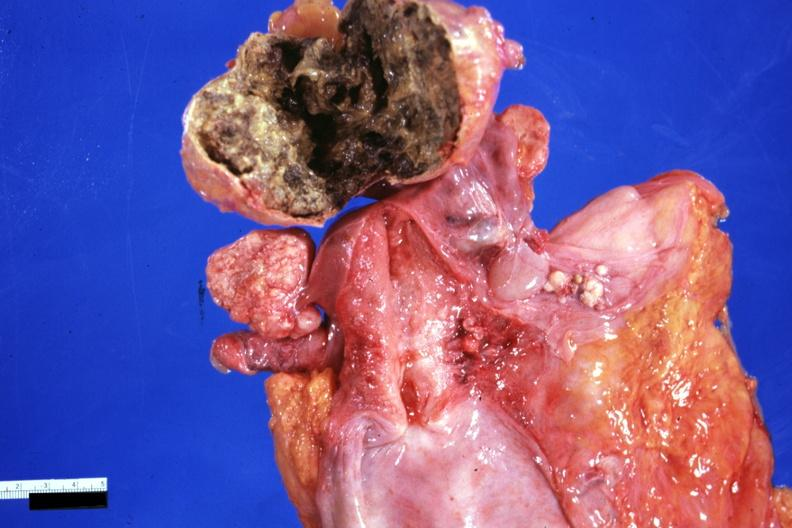s fibrotic lesion present?
Answer the question using a single word or phrase. No 